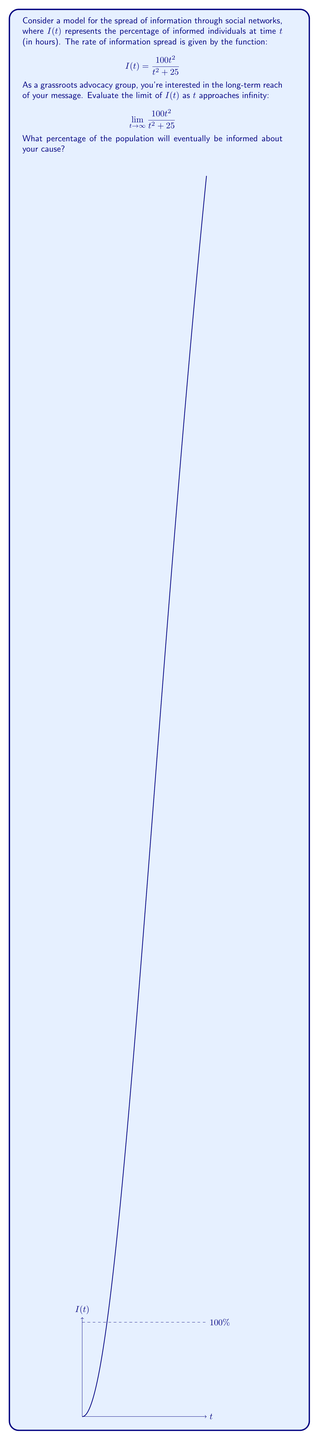Can you answer this question? To evaluate this limit, we'll follow these steps:

1) First, observe that both the numerator and denominator involve $t^2$ terms, which grow faster than any other term as $t$ approaches infinity.

2) We can factor out $t^2$ from both the numerator and denominator:

   $$\lim_{t \to \infty} \frac{100t^2}{t^2 + 25} = \lim_{t \to \infty} \frac{100t^2}{t^2(1 + \frac{25}{t^2})}$$

3) Simplify:

   $$\lim_{t \to \infty} \frac{100}{1 + \frac{25}{t^2}}$$

4) As $t$ approaches infinity, $\frac{25}{t^2}$ approaches 0:

   $$\lim_{t \to \infty} \frac{100}{1 + 0} = \frac{100}{1} = 100$$

Therefore, as time approaches infinity, the percentage of informed individuals approaches 100%.

This result suggests that in the long run, your grassroots advocacy group's message will reach the entire population, maximizing your impact.
Answer: 100% 